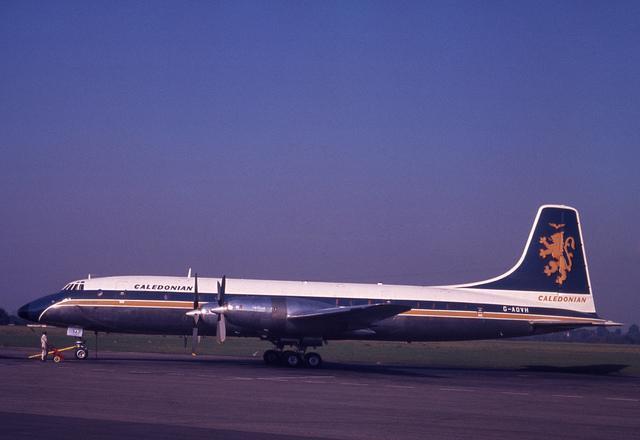How many orange cars are there in the picture?
Give a very brief answer. 0. 